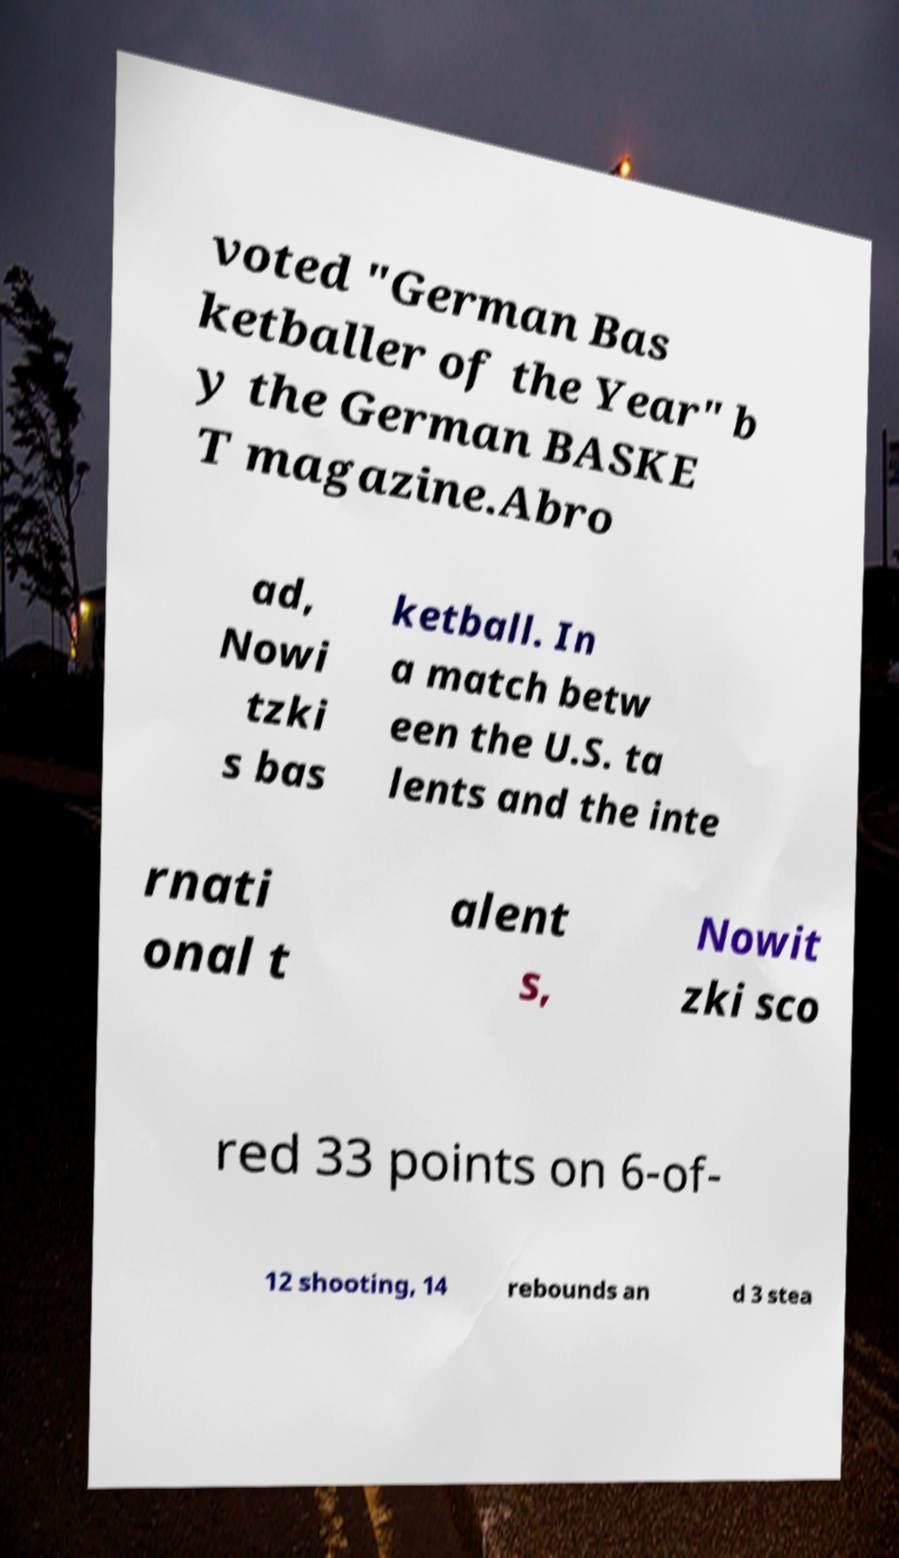Can you read and provide the text displayed in the image?This photo seems to have some interesting text. Can you extract and type it out for me? voted "German Bas ketballer of the Year" b y the German BASKE T magazine.Abro ad, Nowi tzki s bas ketball. In a match betw een the U.S. ta lents and the inte rnati onal t alent s, Nowit zki sco red 33 points on 6-of- 12 shooting, 14 rebounds an d 3 stea 